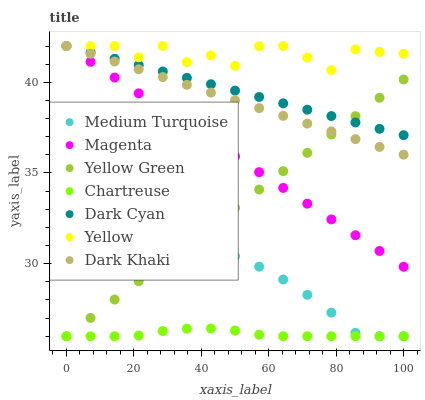Does Chartreuse have the minimum area under the curve?
Answer yes or no. Yes. Does Yellow have the maximum area under the curve?
Answer yes or no. Yes. Does Dark Khaki have the minimum area under the curve?
Answer yes or no. No. Does Dark Khaki have the maximum area under the curve?
Answer yes or no. No. Is Dark Cyan the smoothest?
Answer yes or no. Yes. Is Yellow the roughest?
Answer yes or no. Yes. Is Dark Khaki the smoothest?
Answer yes or no. No. Is Dark Khaki the roughest?
Answer yes or no. No. Does Yellow Green have the lowest value?
Answer yes or no. Yes. Does Dark Khaki have the lowest value?
Answer yes or no. No. Does Magenta have the highest value?
Answer yes or no. Yes. Does Chartreuse have the highest value?
Answer yes or no. No. Is Medium Turquoise less than Magenta?
Answer yes or no. Yes. Is Magenta greater than Medium Turquoise?
Answer yes or no. Yes. Does Dark Cyan intersect Yellow?
Answer yes or no. Yes. Is Dark Cyan less than Yellow?
Answer yes or no. No. Is Dark Cyan greater than Yellow?
Answer yes or no. No. Does Medium Turquoise intersect Magenta?
Answer yes or no. No. 